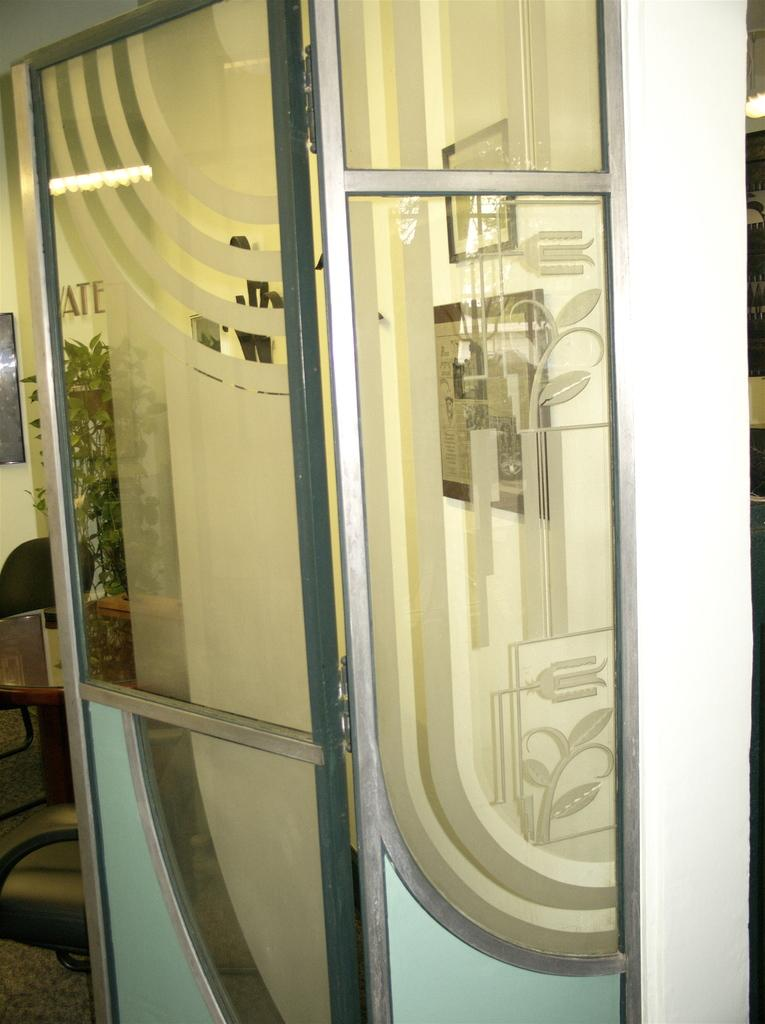What type of door is visible in the image? There is a glass door in the image. What can be seen in the background of the image? There is a table, a chair, and plants in the background of the image. What type of beef is being served on the table in the image? There is no beef present in the image; it only features a glass door, a table, a chair, and plants. 